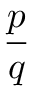<formula> <loc_0><loc_0><loc_500><loc_500>\frac { p } { q }</formula> 